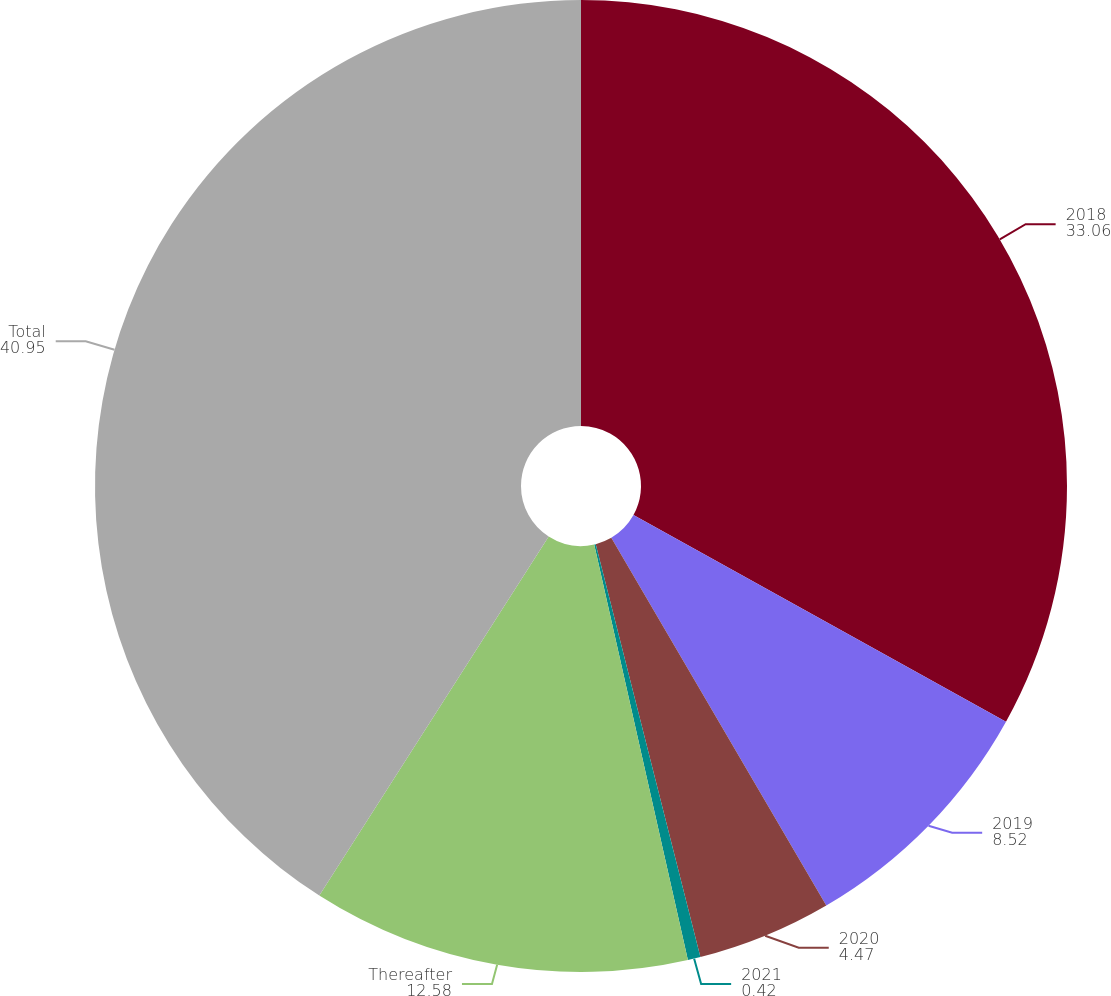Convert chart to OTSL. <chart><loc_0><loc_0><loc_500><loc_500><pie_chart><fcel>2018<fcel>2019<fcel>2020<fcel>2021<fcel>Thereafter<fcel>Total<nl><fcel>33.06%<fcel>8.52%<fcel>4.47%<fcel>0.42%<fcel>12.58%<fcel>40.95%<nl></chart> 